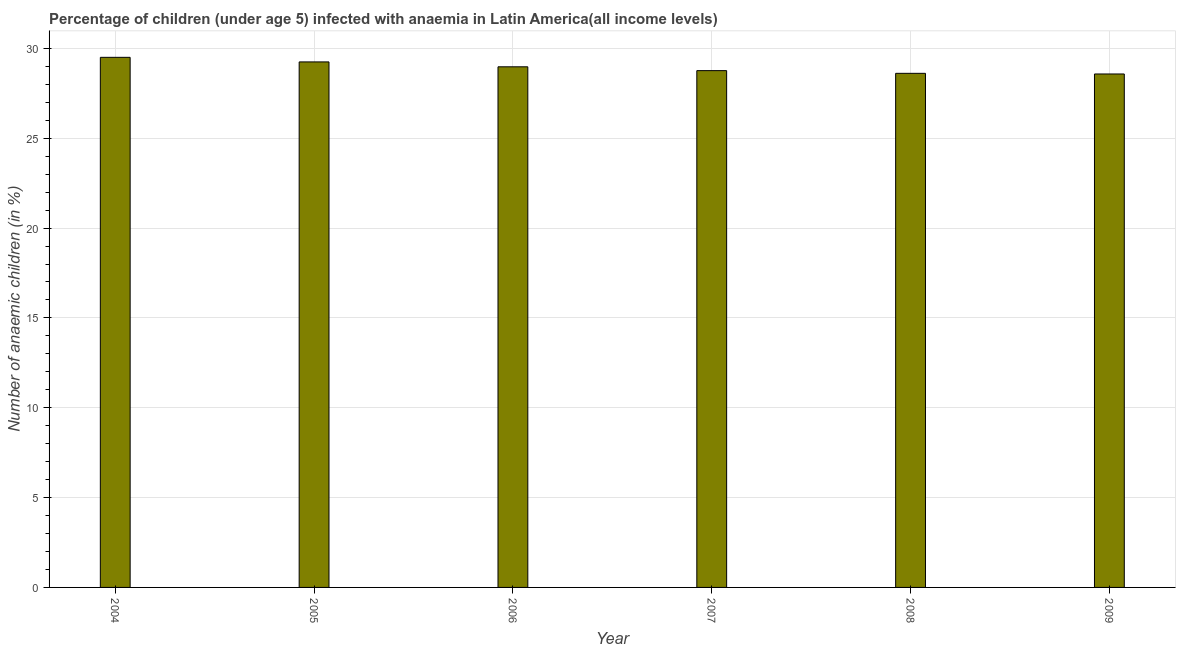Does the graph contain grids?
Offer a terse response. Yes. What is the title of the graph?
Ensure brevity in your answer.  Percentage of children (under age 5) infected with anaemia in Latin America(all income levels). What is the label or title of the X-axis?
Your answer should be very brief. Year. What is the label or title of the Y-axis?
Provide a succinct answer. Number of anaemic children (in %). What is the number of anaemic children in 2007?
Give a very brief answer. 28.76. Across all years, what is the maximum number of anaemic children?
Your answer should be compact. 29.5. Across all years, what is the minimum number of anaemic children?
Your response must be concise. 28.58. In which year was the number of anaemic children maximum?
Make the answer very short. 2004. In which year was the number of anaemic children minimum?
Ensure brevity in your answer.  2009. What is the sum of the number of anaemic children?
Offer a very short reply. 173.68. What is the difference between the number of anaemic children in 2006 and 2007?
Give a very brief answer. 0.21. What is the average number of anaemic children per year?
Keep it short and to the point. 28.95. What is the median number of anaemic children?
Your answer should be very brief. 28.87. What is the ratio of the number of anaemic children in 2004 to that in 2007?
Make the answer very short. 1.03. What is the difference between the highest and the second highest number of anaemic children?
Offer a terse response. 0.26. Is the sum of the number of anaemic children in 2004 and 2007 greater than the maximum number of anaemic children across all years?
Offer a terse response. Yes. How many bars are there?
Give a very brief answer. 6. Are the values on the major ticks of Y-axis written in scientific E-notation?
Your answer should be very brief. No. What is the Number of anaemic children (in %) of 2004?
Your response must be concise. 29.5. What is the Number of anaemic children (in %) of 2005?
Give a very brief answer. 29.25. What is the Number of anaemic children (in %) of 2006?
Give a very brief answer. 28.98. What is the Number of anaemic children (in %) of 2007?
Provide a short and direct response. 28.76. What is the Number of anaemic children (in %) of 2008?
Offer a very short reply. 28.61. What is the Number of anaemic children (in %) of 2009?
Make the answer very short. 28.58. What is the difference between the Number of anaemic children (in %) in 2004 and 2005?
Make the answer very short. 0.26. What is the difference between the Number of anaemic children (in %) in 2004 and 2006?
Make the answer very short. 0.53. What is the difference between the Number of anaemic children (in %) in 2004 and 2007?
Provide a short and direct response. 0.74. What is the difference between the Number of anaemic children (in %) in 2004 and 2008?
Provide a succinct answer. 0.89. What is the difference between the Number of anaemic children (in %) in 2004 and 2009?
Keep it short and to the point. 0.93. What is the difference between the Number of anaemic children (in %) in 2005 and 2006?
Give a very brief answer. 0.27. What is the difference between the Number of anaemic children (in %) in 2005 and 2007?
Your answer should be very brief. 0.48. What is the difference between the Number of anaemic children (in %) in 2005 and 2008?
Your answer should be very brief. 0.64. What is the difference between the Number of anaemic children (in %) in 2005 and 2009?
Your answer should be very brief. 0.67. What is the difference between the Number of anaemic children (in %) in 2006 and 2007?
Your answer should be very brief. 0.21. What is the difference between the Number of anaemic children (in %) in 2006 and 2008?
Make the answer very short. 0.36. What is the difference between the Number of anaemic children (in %) in 2006 and 2009?
Provide a succinct answer. 0.4. What is the difference between the Number of anaemic children (in %) in 2007 and 2008?
Give a very brief answer. 0.15. What is the difference between the Number of anaemic children (in %) in 2007 and 2009?
Make the answer very short. 0.19. What is the difference between the Number of anaemic children (in %) in 2008 and 2009?
Offer a terse response. 0.04. What is the ratio of the Number of anaemic children (in %) in 2004 to that in 2005?
Give a very brief answer. 1.01. What is the ratio of the Number of anaemic children (in %) in 2004 to that in 2007?
Give a very brief answer. 1.03. What is the ratio of the Number of anaemic children (in %) in 2004 to that in 2008?
Offer a terse response. 1.03. What is the ratio of the Number of anaemic children (in %) in 2004 to that in 2009?
Provide a short and direct response. 1.03. What is the ratio of the Number of anaemic children (in %) in 2005 to that in 2006?
Give a very brief answer. 1.01. What is the ratio of the Number of anaemic children (in %) in 2005 to that in 2007?
Keep it short and to the point. 1.02. What is the ratio of the Number of anaemic children (in %) in 2005 to that in 2008?
Provide a short and direct response. 1.02. What is the ratio of the Number of anaemic children (in %) in 2005 to that in 2009?
Make the answer very short. 1.02. What is the ratio of the Number of anaemic children (in %) in 2006 to that in 2007?
Your answer should be very brief. 1.01. What is the ratio of the Number of anaemic children (in %) in 2006 to that in 2009?
Offer a very short reply. 1.01. 